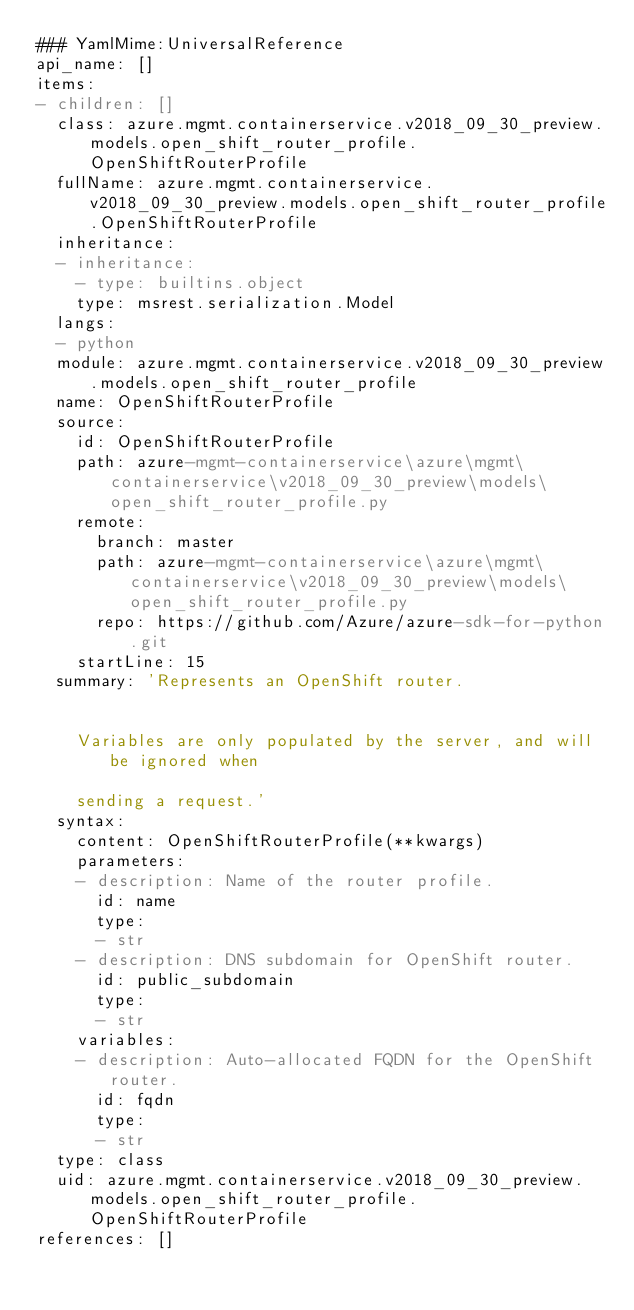Convert code to text. <code><loc_0><loc_0><loc_500><loc_500><_YAML_>### YamlMime:UniversalReference
api_name: []
items:
- children: []
  class: azure.mgmt.containerservice.v2018_09_30_preview.models.open_shift_router_profile.OpenShiftRouterProfile
  fullName: azure.mgmt.containerservice.v2018_09_30_preview.models.open_shift_router_profile.OpenShiftRouterProfile
  inheritance:
  - inheritance:
    - type: builtins.object
    type: msrest.serialization.Model
  langs:
  - python
  module: azure.mgmt.containerservice.v2018_09_30_preview.models.open_shift_router_profile
  name: OpenShiftRouterProfile
  source:
    id: OpenShiftRouterProfile
    path: azure-mgmt-containerservice\azure\mgmt\containerservice\v2018_09_30_preview\models\open_shift_router_profile.py
    remote:
      branch: master
      path: azure-mgmt-containerservice\azure\mgmt\containerservice\v2018_09_30_preview\models\open_shift_router_profile.py
      repo: https://github.com/Azure/azure-sdk-for-python.git
    startLine: 15
  summary: 'Represents an OpenShift router.


    Variables are only populated by the server, and will be ignored when

    sending a request.'
  syntax:
    content: OpenShiftRouterProfile(**kwargs)
    parameters:
    - description: Name of the router profile.
      id: name
      type:
      - str
    - description: DNS subdomain for OpenShift router.
      id: public_subdomain
      type:
      - str
    variables:
    - description: Auto-allocated FQDN for the OpenShift router.
      id: fqdn
      type:
      - str
  type: class
  uid: azure.mgmt.containerservice.v2018_09_30_preview.models.open_shift_router_profile.OpenShiftRouterProfile
references: []
</code> 